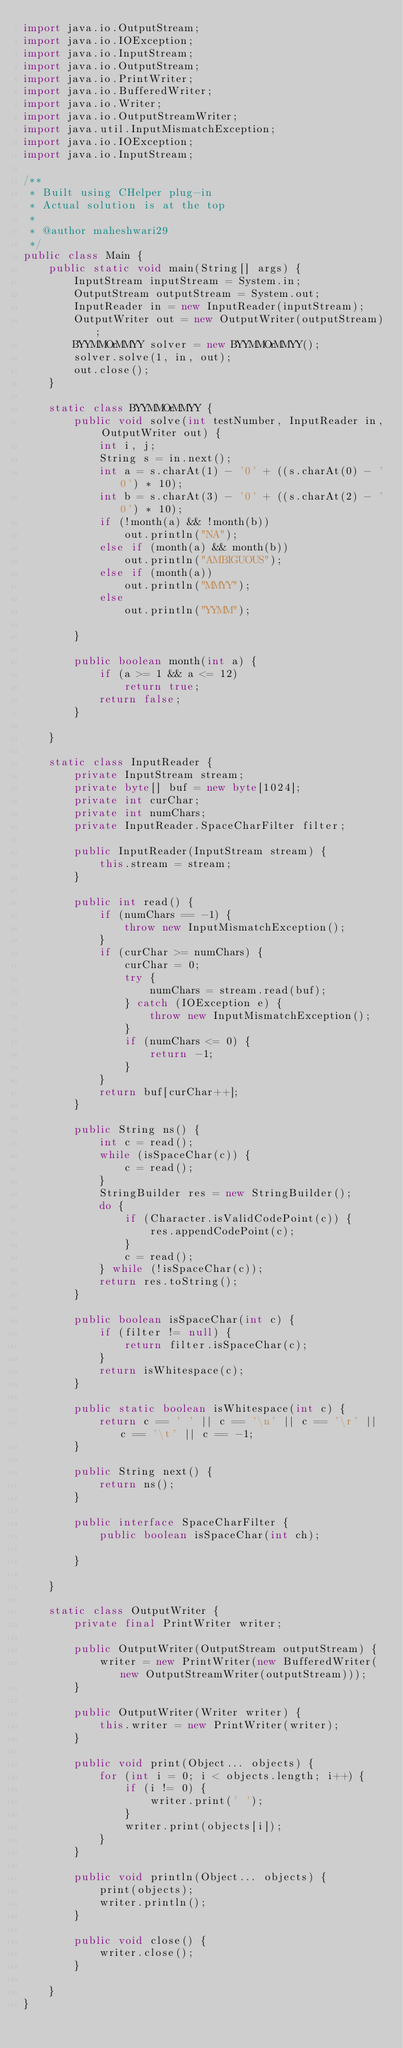<code> <loc_0><loc_0><loc_500><loc_500><_Java_>import java.io.OutputStream;
import java.io.IOException;
import java.io.InputStream;
import java.io.OutputStream;
import java.io.PrintWriter;
import java.io.BufferedWriter;
import java.io.Writer;
import java.io.OutputStreamWriter;
import java.util.InputMismatchException;
import java.io.IOException;
import java.io.InputStream;

/**
 * Built using CHelper plug-in
 * Actual solution is at the top
 *
 * @author maheshwari29
 */
public class Main {
    public static void main(String[] args) {
        InputStream inputStream = System.in;
        OutputStream outputStream = System.out;
        InputReader in = new InputReader(inputStream);
        OutputWriter out = new OutputWriter(outputStream);
        BYYMMOrMMYY solver = new BYYMMOrMMYY();
        solver.solve(1, in, out);
        out.close();
    }

    static class BYYMMOrMMYY {
        public void solve(int testNumber, InputReader in, OutputWriter out) {
            int i, j;
            String s = in.next();
            int a = s.charAt(1) - '0' + ((s.charAt(0) - '0') * 10);
            int b = s.charAt(3) - '0' + ((s.charAt(2) - '0') * 10);
            if (!month(a) && !month(b))
                out.println("NA");
            else if (month(a) && month(b))
                out.println("AMBIGUOUS");
            else if (month(a))
                out.println("MMYY");
            else
                out.println("YYMM");

        }

        public boolean month(int a) {
            if (a >= 1 && a <= 12)
                return true;
            return false;
        }

    }

    static class InputReader {
        private InputStream stream;
        private byte[] buf = new byte[1024];
        private int curChar;
        private int numChars;
        private InputReader.SpaceCharFilter filter;

        public InputReader(InputStream stream) {
            this.stream = stream;
        }

        public int read() {
            if (numChars == -1) {
                throw new InputMismatchException();
            }
            if (curChar >= numChars) {
                curChar = 0;
                try {
                    numChars = stream.read(buf);
                } catch (IOException e) {
                    throw new InputMismatchException();
                }
                if (numChars <= 0) {
                    return -1;
                }
            }
            return buf[curChar++];
        }

        public String ns() {
            int c = read();
            while (isSpaceChar(c)) {
                c = read();
            }
            StringBuilder res = new StringBuilder();
            do {
                if (Character.isValidCodePoint(c)) {
                    res.appendCodePoint(c);
                }
                c = read();
            } while (!isSpaceChar(c));
            return res.toString();
        }

        public boolean isSpaceChar(int c) {
            if (filter != null) {
                return filter.isSpaceChar(c);
            }
            return isWhitespace(c);
        }

        public static boolean isWhitespace(int c) {
            return c == ' ' || c == '\n' || c == '\r' || c == '\t' || c == -1;
        }

        public String next() {
            return ns();
        }

        public interface SpaceCharFilter {
            public boolean isSpaceChar(int ch);

        }

    }

    static class OutputWriter {
        private final PrintWriter writer;

        public OutputWriter(OutputStream outputStream) {
            writer = new PrintWriter(new BufferedWriter(new OutputStreamWriter(outputStream)));
        }

        public OutputWriter(Writer writer) {
            this.writer = new PrintWriter(writer);
        }

        public void print(Object... objects) {
            for (int i = 0; i < objects.length; i++) {
                if (i != 0) {
                    writer.print(' ');
                }
                writer.print(objects[i]);
            }
        }

        public void println(Object... objects) {
            print(objects);
            writer.println();
        }

        public void close() {
            writer.close();
        }

    }
}

</code> 